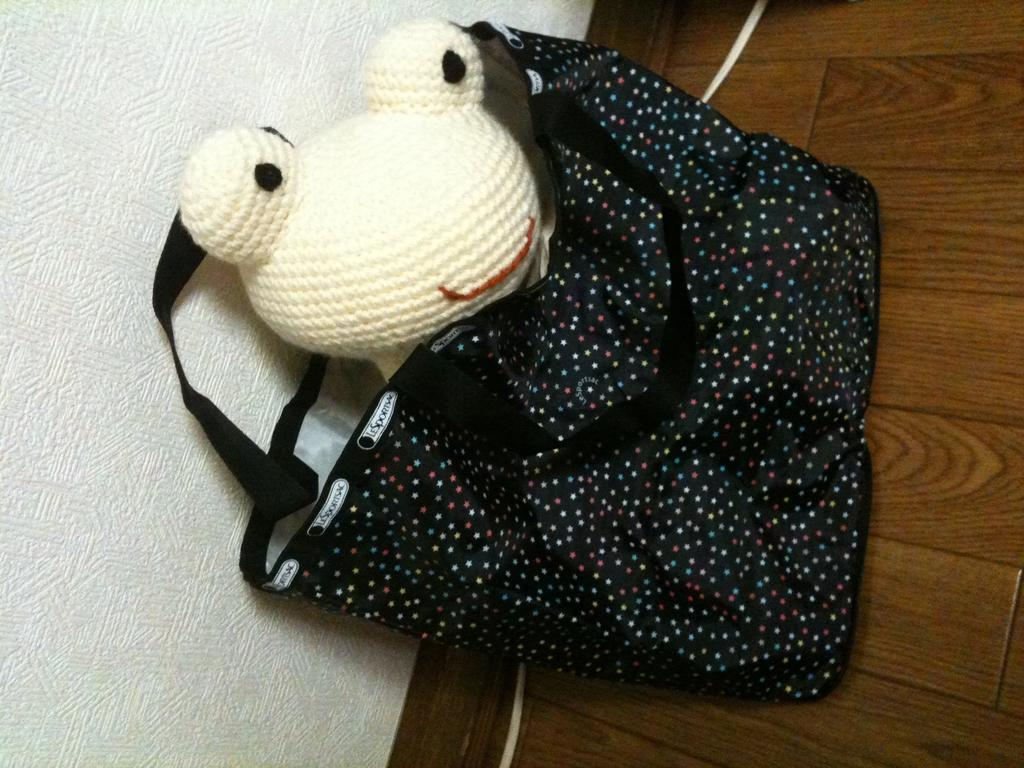What is the color of the bag in the image? The bag in the image is black. What is inside the bag? A toy is placed inside the bag. What type of flooring can be seen in the background of the image? There is a wooden floor visible in the background of the image. Can you see any passengers or streams in the image? No, there are no passengers or streams present in the image. 